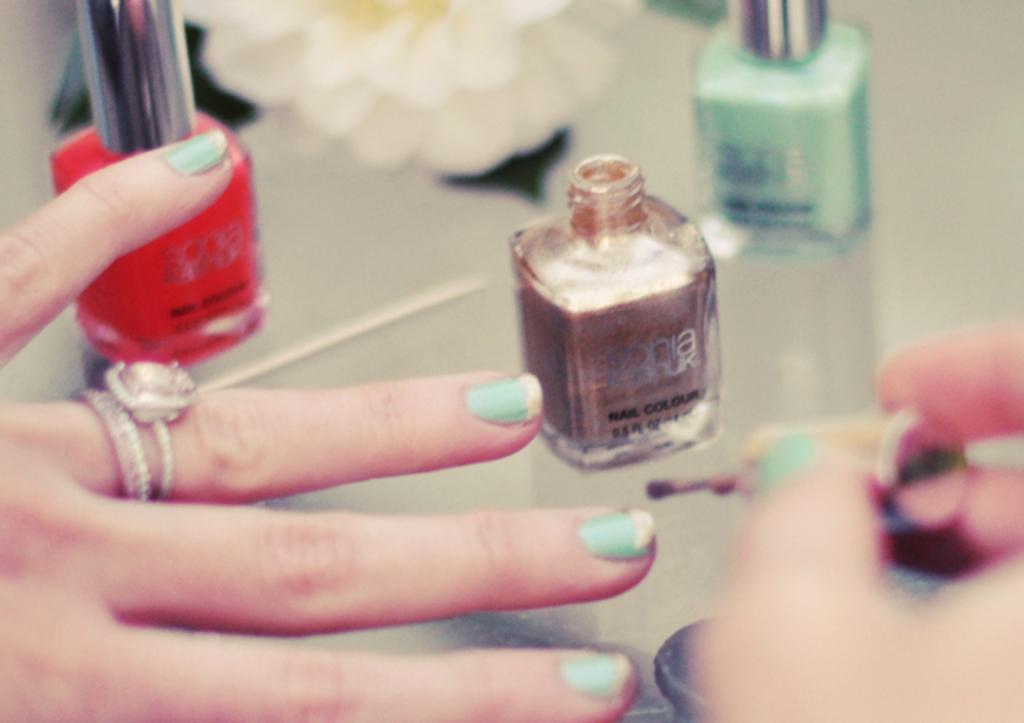<image>
Create a compact narrative representing the image presented. A close up of a women's hand with a jar that says nail color. 